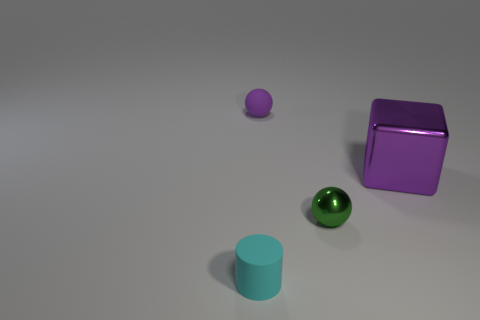Add 4 big cylinders. How many objects exist? 8 Subtract all cylinders. How many objects are left? 3 Subtract all big gray matte things. Subtract all balls. How many objects are left? 2 Add 3 large purple things. How many large purple things are left? 4 Add 4 big objects. How many big objects exist? 5 Subtract 0 gray cylinders. How many objects are left? 4 